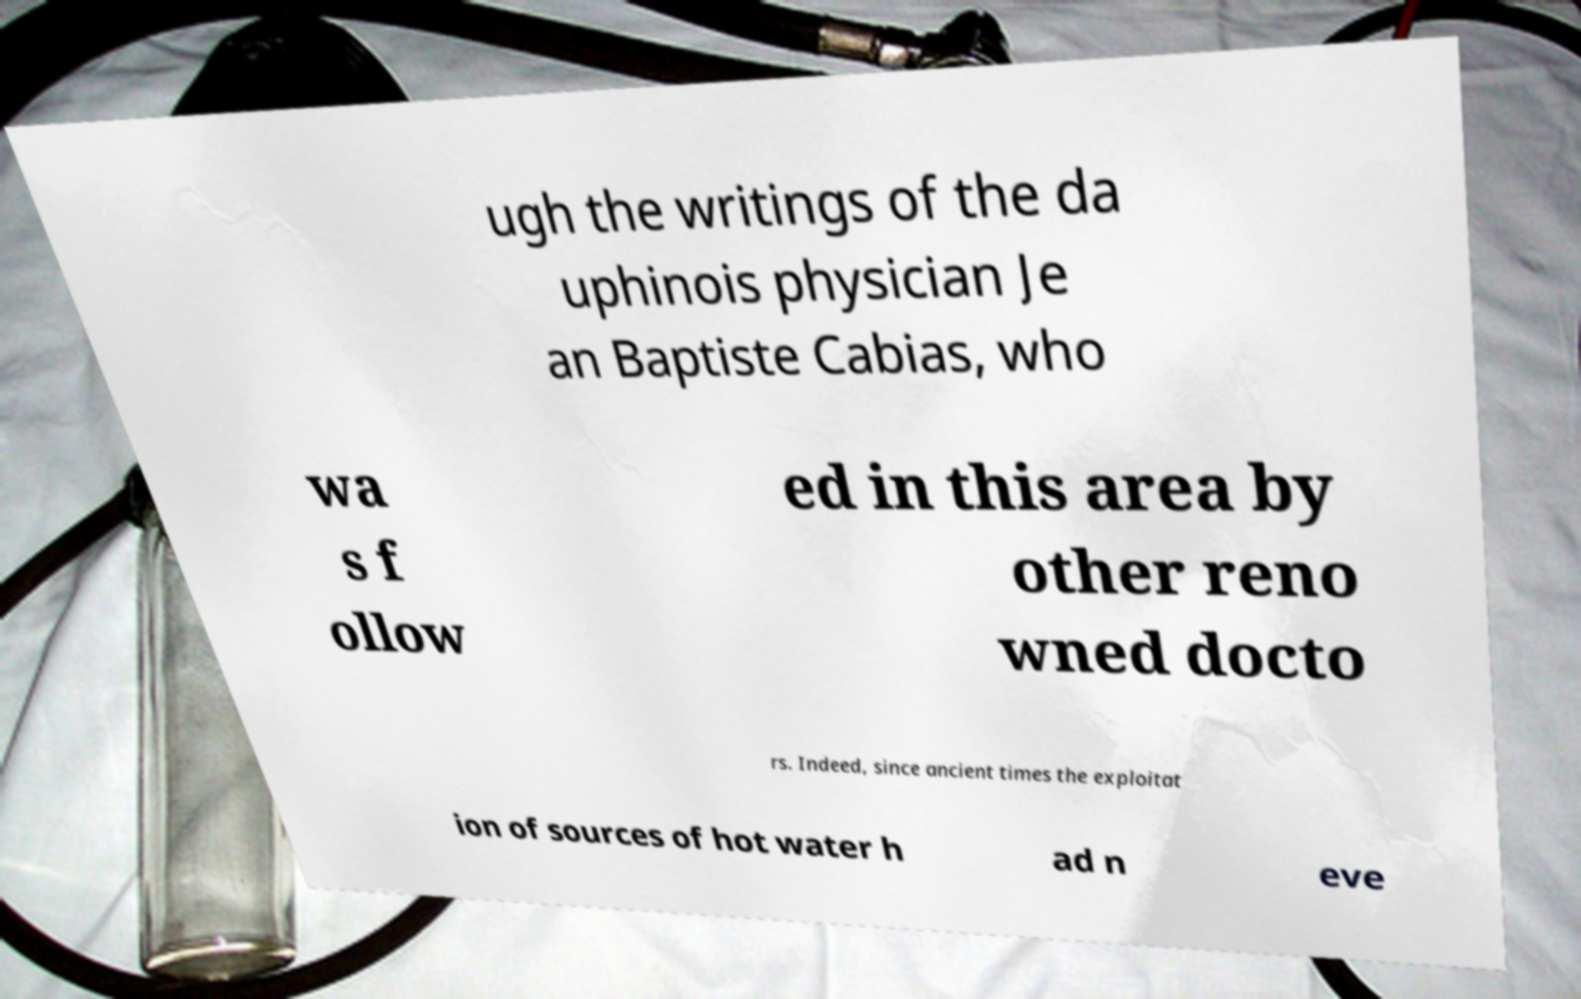Can you accurately transcribe the text from the provided image for me? ugh the writings of the da uphinois physician Je an Baptiste Cabias, who wa s f ollow ed in this area by other reno wned docto rs. Indeed, since ancient times the exploitat ion of sources of hot water h ad n eve 